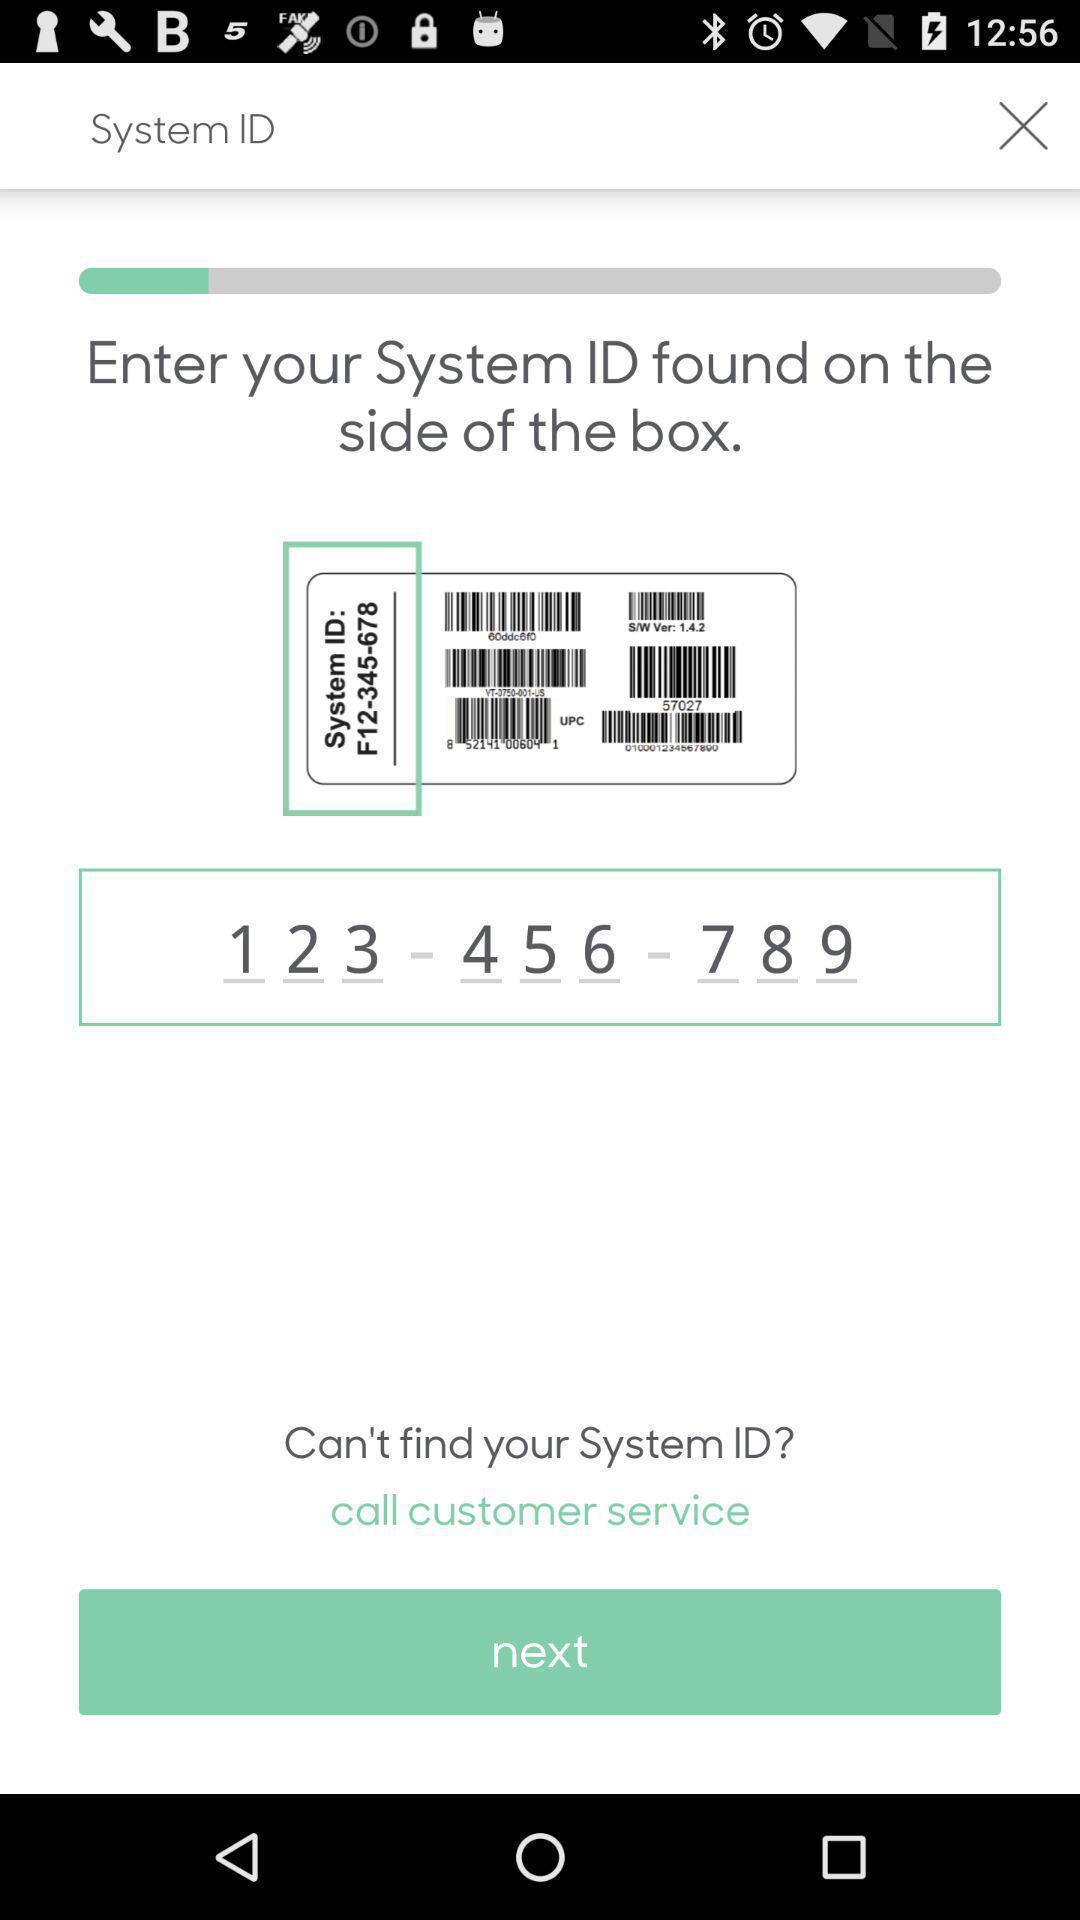Explain the elements present in this screenshot. Screen showing the field to enter the system id. 